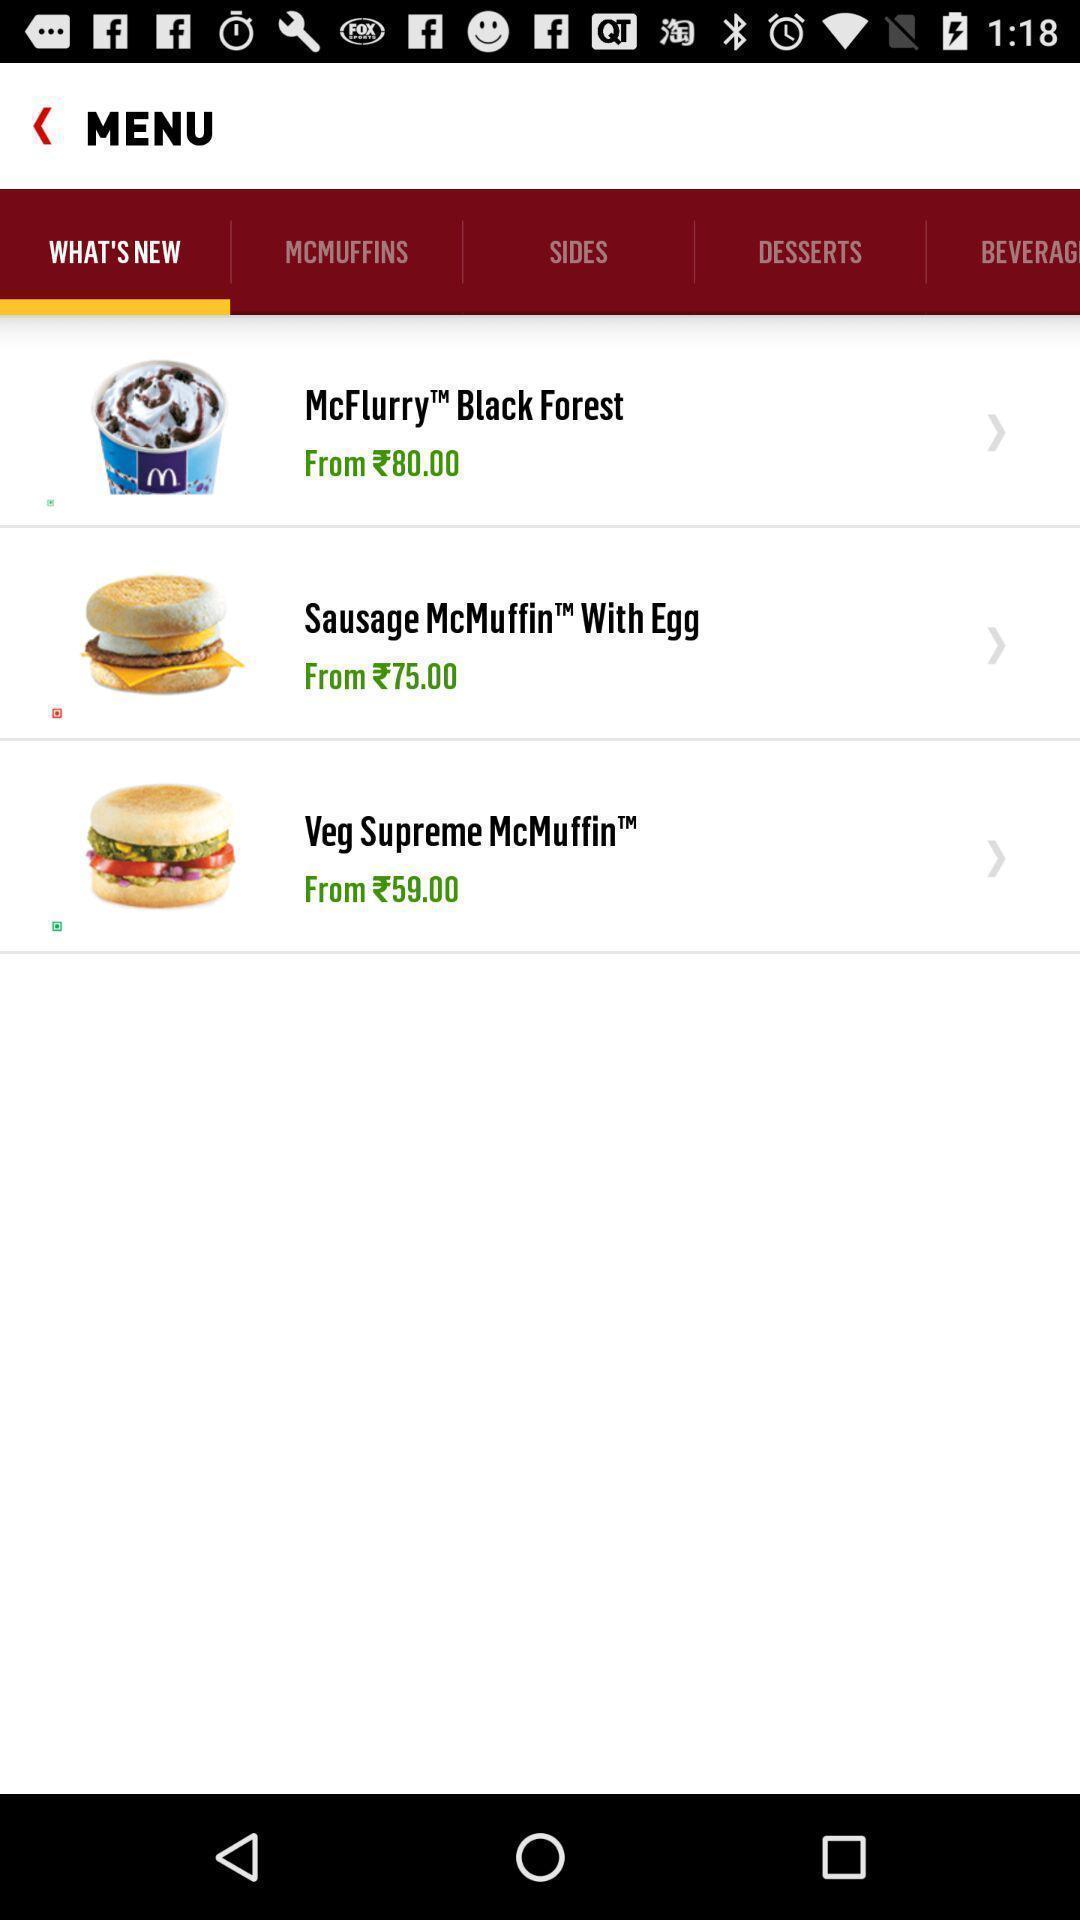What is the overall content of this screenshot? Screen page of a food menu. 